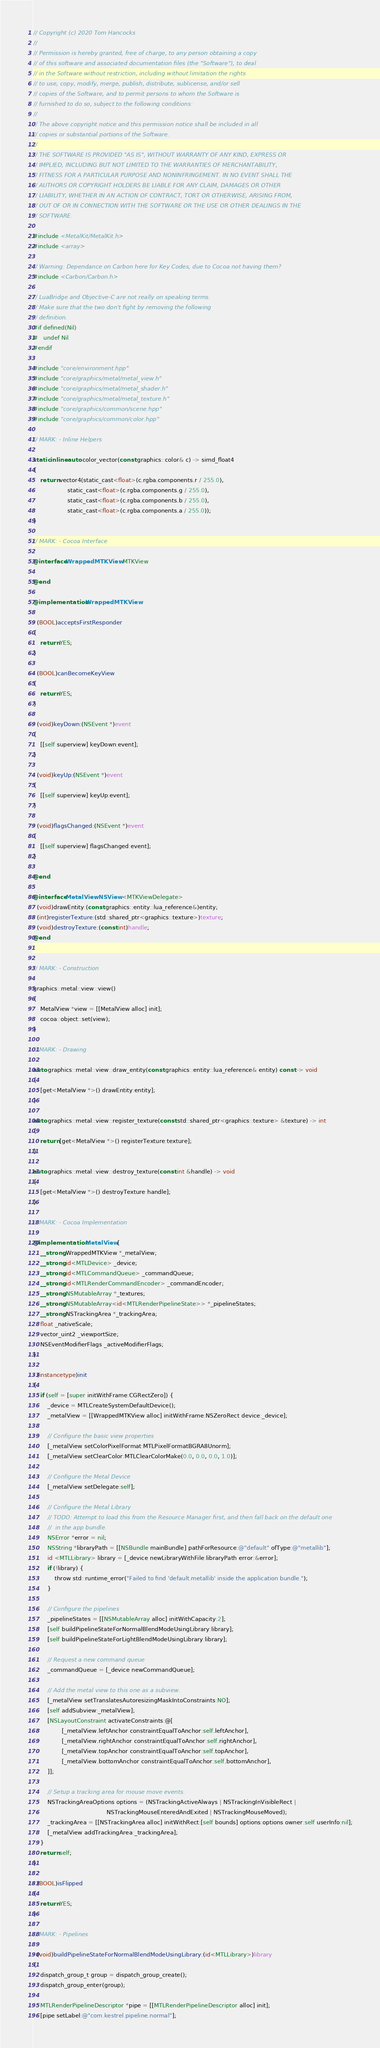<code> <loc_0><loc_0><loc_500><loc_500><_ObjectiveC_>// Copyright (c) 2020 Tom Hancocks
//
// Permission is hereby granted, free of charge, to any person obtaining a copy
// of this software and associated documentation files (the "Software"), to deal
// in the Software without restriction, including without limitation the rights
// to use, copy, modify, merge, publish, distribute, sublicense, and/or sell
// copies of the Software, and to permit persons to whom the Software is
// furnished to do so, subject to the following conditions:
//
// The above copyright notice and this permission notice shall be included in all
// copies or substantial portions of the Software.
//
// THE SOFTWARE IS PROVIDED "AS IS", WITHOUT WARRANTY OF ANY KIND, EXPRESS OR
// IMPLIED, INCLUDING BUT NOT LIMITED TO THE WARRANTIES OF MERCHANTABILITY,
// FITNESS FOR A PARTICULAR PURPOSE AND NONINFRINGEMENT. IN NO EVENT SHALL THE
// AUTHORS OR COPYRIGHT HOLDERS BE LIABLE FOR ANY CLAIM, DAMAGES OR OTHER
// LIABILITY, WHETHER IN AN ACTION OF CONTRACT, TORT OR OTHERWISE, ARISING FROM,
// OUT OF OR IN CONNECTION WITH THE SOFTWARE OR THE USE OR OTHER DEALINGS IN THE
// SOFTWARE.

#include <MetalKit/MetalKit.h>
#include <array>

// Warning: Dependance on Carbon here for Key Codes, due to Cocoa not having them?
#include <Carbon/Carbon.h>

// LuaBridge and Objective-C are not really on speaking terms.
// Make sure that the two don't fight by removing the following
// definition.
#if defined(Nil)
#   undef Nil
#endif

#include "core/environment.hpp"
#include "core/graphics/metal/metal_view.h"
#include "core/graphics/metal/metal_shader.h"
#include "core/graphics/metal/metal_texture.h"
#include "core/graphics/common/scene.hpp"
#include "core/graphics/common/color.hpp"

// MARK: - Inline Helpers

static inline auto color_vector(const graphics::color& c) -> simd_float4
{
    return vector4(static_cast<float>(c.rgba.components.r / 255.0),
                   static_cast<float>(c.rgba.components.g / 255.0),
                   static_cast<float>(c.rgba.components.b / 255.0),
                   static_cast<float>(c.rgba.components.a / 255.0));
}

// MARK: - Cocoa Interface

@interface WrappedMTKView : MTKView

@end

@implementation WrappedMTKView

- (BOOL)acceptsFirstResponder
{
    return YES;
}

- (BOOL)canBecomeKeyView
{
    return YES;
}

- (void)keyDown:(NSEvent *)event
{
    [[self superview] keyDown:event];
}

- (void)keyUp:(NSEvent *)event
{
    [[self superview] keyUp:event];
}

- (void)flagsChanged:(NSEvent *)event
{
    [[self superview] flagsChanged:event];
}

@end

@interface MetalView: NSView <MTKViewDelegate>
- (void)drawEntity:(const graphics::entity::lua_reference&)entity;
- (int)registerTexture:(std::shared_ptr<graphics::texture>)texture;
- (void)destroyTexture:(const int)handle;
@end


// MARK: - Construction

graphics::metal::view::view()
{
    MetalView *view = [[MetalView alloc] init];
    cocoa::object::set(view);
}

// MARK: - Drawing

auto graphics::metal::view::draw_entity(const graphics::entity::lua_reference& entity) const -> void
{
    [get<MetalView *>() drawEntity:entity];
}

auto graphics::metal::view::register_texture(const std::shared_ptr<graphics::texture> &texture) -> int
{
    return [get<MetalView *>() registerTexture:texture];
}

auto graphics::metal::view::destroy_texture(const int &handle) -> void
{
    [get<MetalView *>() destroyTexture:handle];
}

// MARK: - Cocoa Implementation

@implementation MetalView {
    __strong WrappedMTKView *_metalView;
    __strong id<MTLDevice> _device;
    __strong id<MTLCommandQueue> _commandQueue;
    __strong id<MTLRenderCommandEncoder> _commandEncoder;
    __strong NSMutableArray *_textures;
    __strong NSMutableArray<id<MTLRenderPipelineState>> *_pipelineStates;
    __strong NSTrackingArea *_trackingArea;
    float _nativeScale;
    vector_uint2 _viewportSize;
    NSEventModifierFlags _activeModifierFlags;
}

- (instancetype)init
{
    if (self = [super initWithFrame:CGRectZero]) {
        _device = MTLCreateSystemDefaultDevice();
        _metalView = [[WrappedMTKView alloc] initWithFrame:NSZeroRect device:_device];

        // Configure the basic view properties
        [_metalView setColorPixelFormat:MTLPixelFormatBGRA8Unorm];
        [_metalView setClearColor:MTLClearColorMake(0.0, 0.0, 0.0, 1.0)];

        // Configure the Metal Device
        [_metalView setDelegate:self];

        // Configure the Metal Library
        // TODO: Attempt to load this from the Resource Manager first, and then fall back on the default one
        //  in the app bundle.
        NSError *error = nil;
        NSString *libraryPath = [[NSBundle mainBundle] pathForResource:@"default" ofType:@"metallib"];
        id <MTLLibrary> library = [_device newLibraryWithFile:libraryPath error:&error];
        if (!library) {
            throw std::runtime_error("Failed to find 'default.metallib' inside the application bundle.");
        }

        // Configure the pipelines
        _pipelineStates = [[NSMutableArray alloc] initWithCapacity:2];
        [self buildPipelineStateForNormalBlendModeUsingLibrary:library];
        [self buildPipelineStateForLightBlendModeUsingLibrary:library];

        // Request a new command queue
        _commandQueue = [_device newCommandQueue];

        // Add the metal view to this one as a subview.
        [_metalView setTranslatesAutoresizingMaskIntoConstraints:NO];
        [self addSubview:_metalView];
        [NSLayoutConstraint activateConstraints:@[
                [_metalView.leftAnchor constraintEqualToAnchor:self.leftAnchor],
                [_metalView.rightAnchor constraintEqualToAnchor:self.rightAnchor],
                [_metalView.topAnchor constraintEqualToAnchor:self.topAnchor],
                [_metalView.bottomAnchor constraintEqualToAnchor:self.bottomAnchor],
        ]];

        // Setup a tracking area for mouse move events.
        NSTrackingAreaOptions options = (NSTrackingActiveAlways | NSTrackingInVisibleRect |
                                         NSTrackingMouseEnteredAndExited | NSTrackingMouseMoved);
        _trackingArea = [[NSTrackingArea alloc] initWithRect:[self bounds] options:options owner:self userInfo:nil];
        [_metalView addTrackingArea:_trackingArea];
    }
    return self;
}

- (BOOL)isFlipped
{
    return YES;
}

// MARK: - Pipelines

- (void)buildPipelineStateForNormalBlendModeUsingLibrary:(id<MTLLibrary>)library
{
    dispatch_group_t group = dispatch_group_create();
    dispatch_group_enter(group);

    MTLRenderPipelineDescriptor *pipe = [[MTLRenderPipelineDescriptor alloc] init];
    [pipe setLabel:@"com.kestrel.pipeline.normal"];</code> 